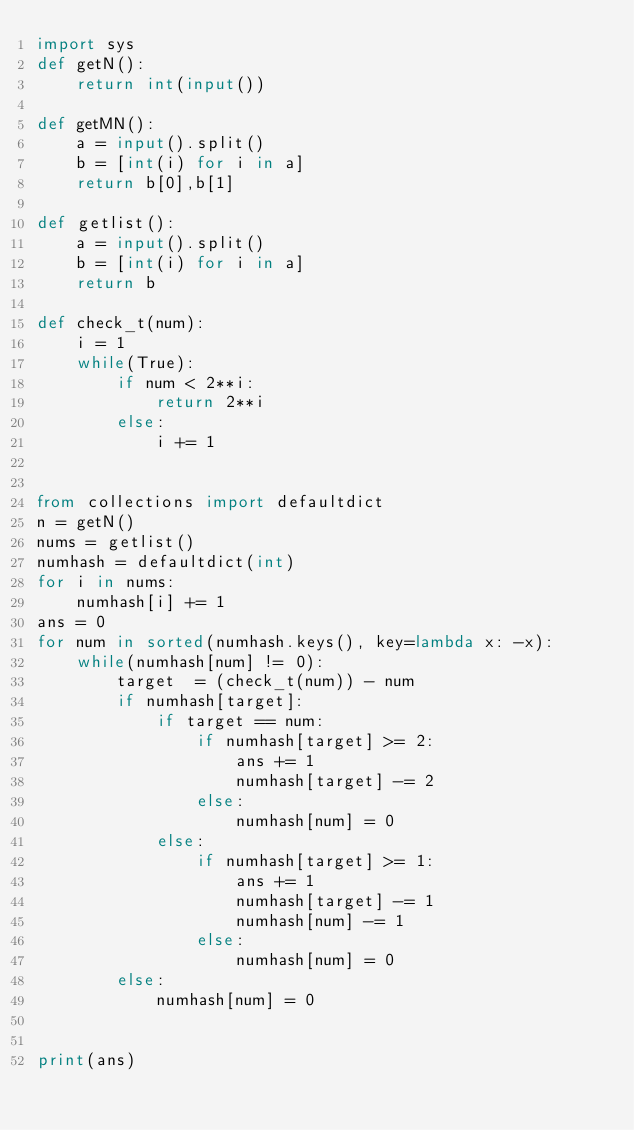<code> <loc_0><loc_0><loc_500><loc_500><_Python_>import sys
def getN():
    return int(input())

def getMN():
    a = input().split()
    b = [int(i) for i in a]
    return b[0],b[1]

def getlist():
    a = input().split()
    b = [int(i) for i in a]
    return b

def check_t(num):
    i = 1
    while(True):
        if num < 2**i:
            return 2**i
        else:
            i += 1


from collections import defaultdict
n = getN()
nums = getlist()
numhash = defaultdict(int)
for i in nums:
    numhash[i] += 1
ans = 0
for num in sorted(numhash.keys(), key=lambda x: -x):
    while(numhash[num] != 0):
        target  = (check_t(num)) - num
        if numhash[target]:
            if target == num:
                if numhash[target] >= 2:
                    ans += 1
                    numhash[target] -= 2
                else:
                    numhash[num] = 0
            else:
                if numhash[target] >= 1:
                    ans += 1
                    numhash[target] -= 1
                    numhash[num] -= 1
                else:
                    numhash[num] = 0
        else:
            numhash[num] = 0


print(ans)
</code> 